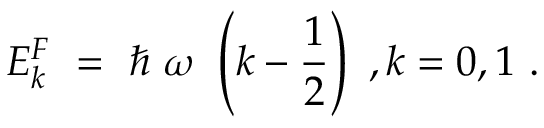<formula> <loc_0><loc_0><loc_500><loc_500>E _ { k } ^ { F } = \hbar { \omega } \left ( k - { \frac { 1 } { 2 } } \right ) , k = 0 , 1 .</formula> 